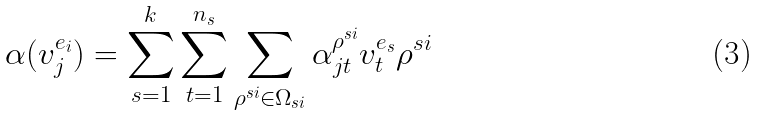Convert formula to latex. <formula><loc_0><loc_0><loc_500><loc_500>\alpha ( v _ { j } ^ { e _ { i } } ) = \sum _ { s = 1 } ^ { k } \sum _ { t = 1 } ^ { n _ { s } } \sum _ { \rho ^ { s i } \in \Omega _ { s i } } \alpha _ { j t } ^ { \rho ^ { s i } } v _ { t } ^ { e _ { s } } \rho ^ { s i }</formula> 